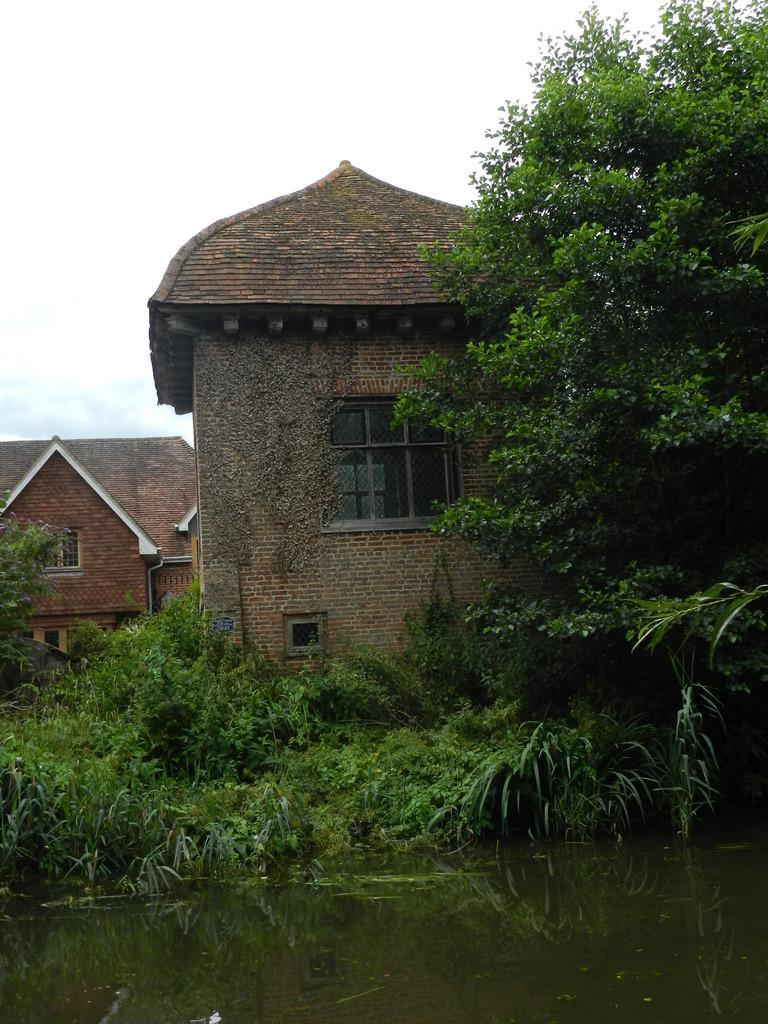What type of structure is present in the image? There is a building in the image. What feature can be seen on the building? The building has windows. What type of vegetation is present in the image? There is a tree and grass in the image. What natural element is visible in the image? Water is visible in the image. What part of the natural environment is visible in the image? The sky is visible in the image. What type of shoes is the writer wearing while sprinkling sugar on the grass in the image? There is no writer, shoes, or sugar present in the image. 